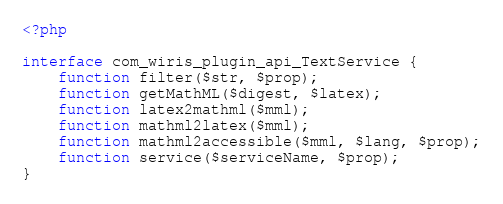Convert code to text. <code><loc_0><loc_0><loc_500><loc_500><_PHP_><?php

interface com_wiris_plugin_api_TextService {
	function filter($str, $prop);
	function getMathML($digest, $latex);
	function latex2mathml($mml);
	function mathml2latex($mml);
	function mathml2accessible($mml, $lang, $prop);
	function service($serviceName, $prop);
}
</code> 